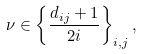<formula> <loc_0><loc_0><loc_500><loc_500>\nu \in \left \{ \frac { d _ { i j } + 1 } { 2 i } \right \} _ { i , j } ,</formula> 